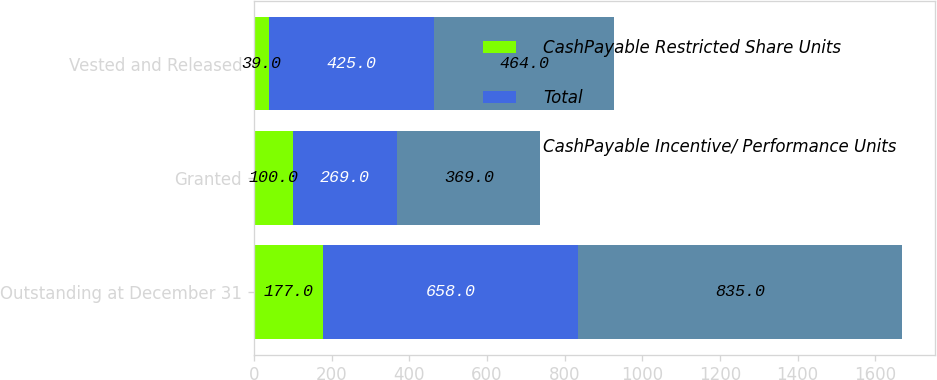<chart> <loc_0><loc_0><loc_500><loc_500><stacked_bar_chart><ecel><fcel>Outstanding at December 31<fcel>Granted<fcel>Vested and Released<nl><fcel>CashPayable Restricted Share Units<fcel>177<fcel>100<fcel>39<nl><fcel>Total<fcel>658<fcel>269<fcel>425<nl><fcel>CashPayable Incentive/ Performance Units<fcel>835<fcel>369<fcel>464<nl></chart> 